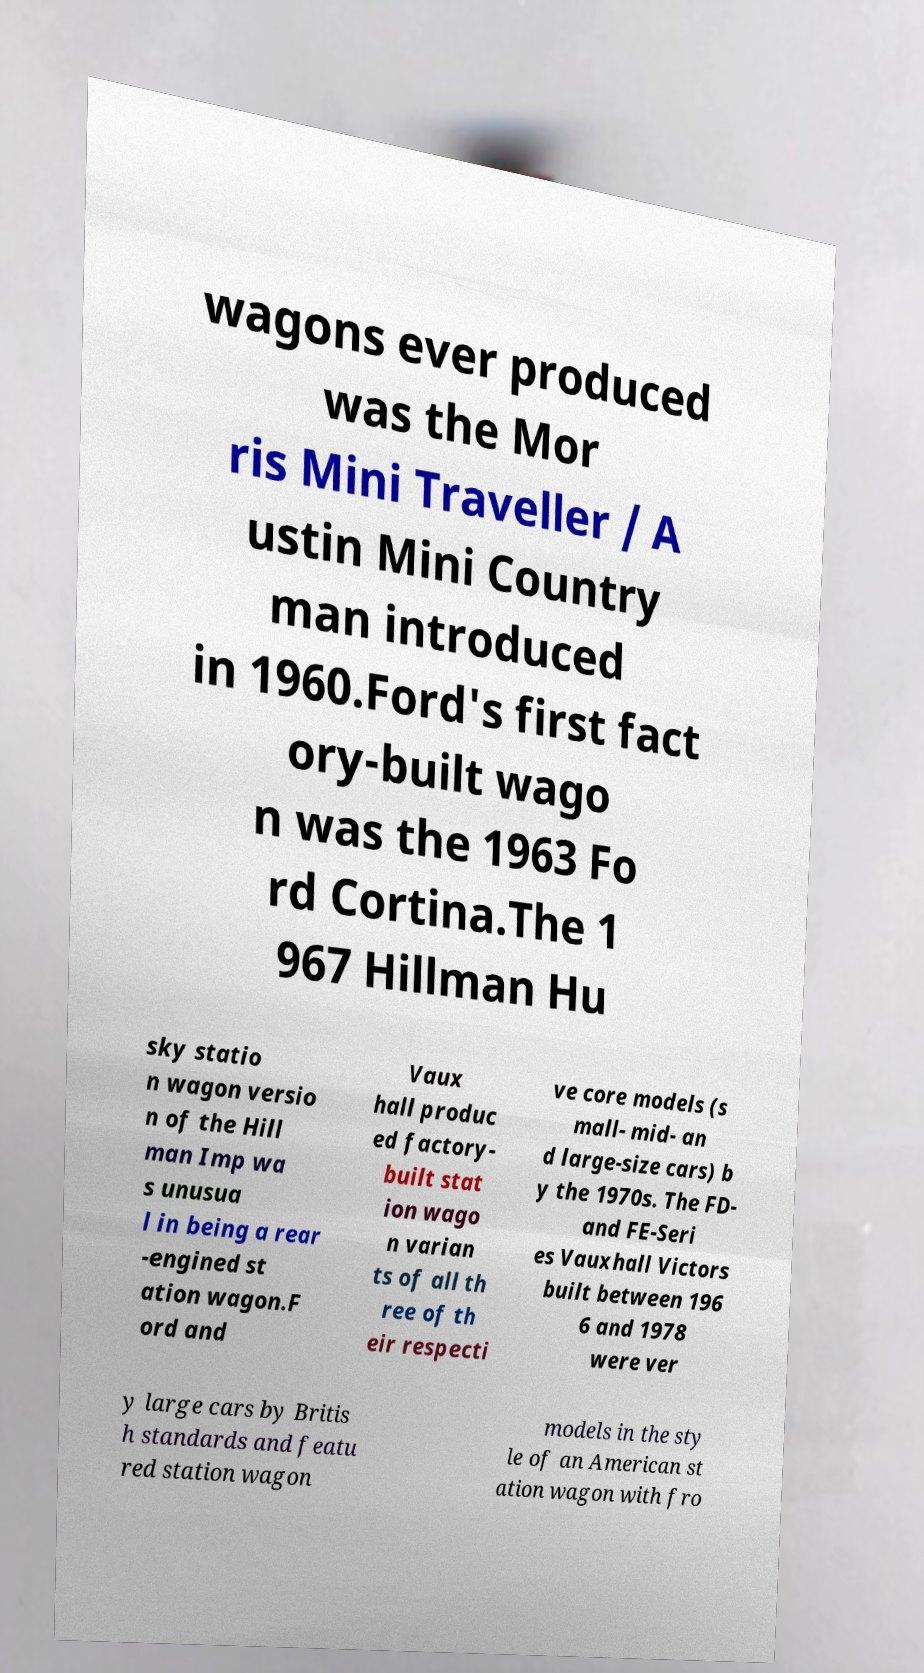What messages or text are displayed in this image? I need them in a readable, typed format. wagons ever produced was the Mor ris Mini Traveller / A ustin Mini Country man introduced in 1960.Ford's first fact ory-built wago n was the 1963 Fo rd Cortina.The 1 967 Hillman Hu sky statio n wagon versio n of the Hill man Imp wa s unusua l in being a rear -engined st ation wagon.F ord and Vaux hall produc ed factory- built stat ion wago n varian ts of all th ree of th eir respecti ve core models (s mall- mid- an d large-size cars) b y the 1970s. The FD- and FE-Seri es Vauxhall Victors built between 196 6 and 1978 were ver y large cars by Britis h standards and featu red station wagon models in the sty le of an American st ation wagon with fro 